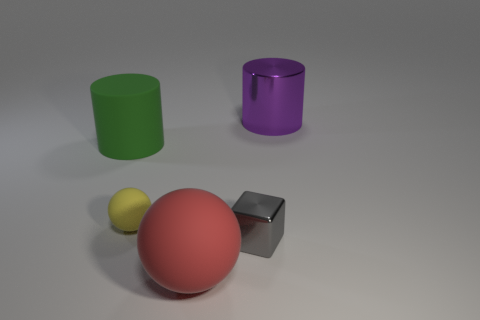Add 2 big brown rubber objects. How many objects exist? 7 Subtract all balls. How many objects are left? 3 Add 4 yellow rubber objects. How many yellow rubber objects are left? 5 Add 1 small yellow matte objects. How many small yellow matte objects exist? 2 Subtract 0 blue spheres. How many objects are left? 5 Subtract all large blue rubber cubes. Subtract all balls. How many objects are left? 3 